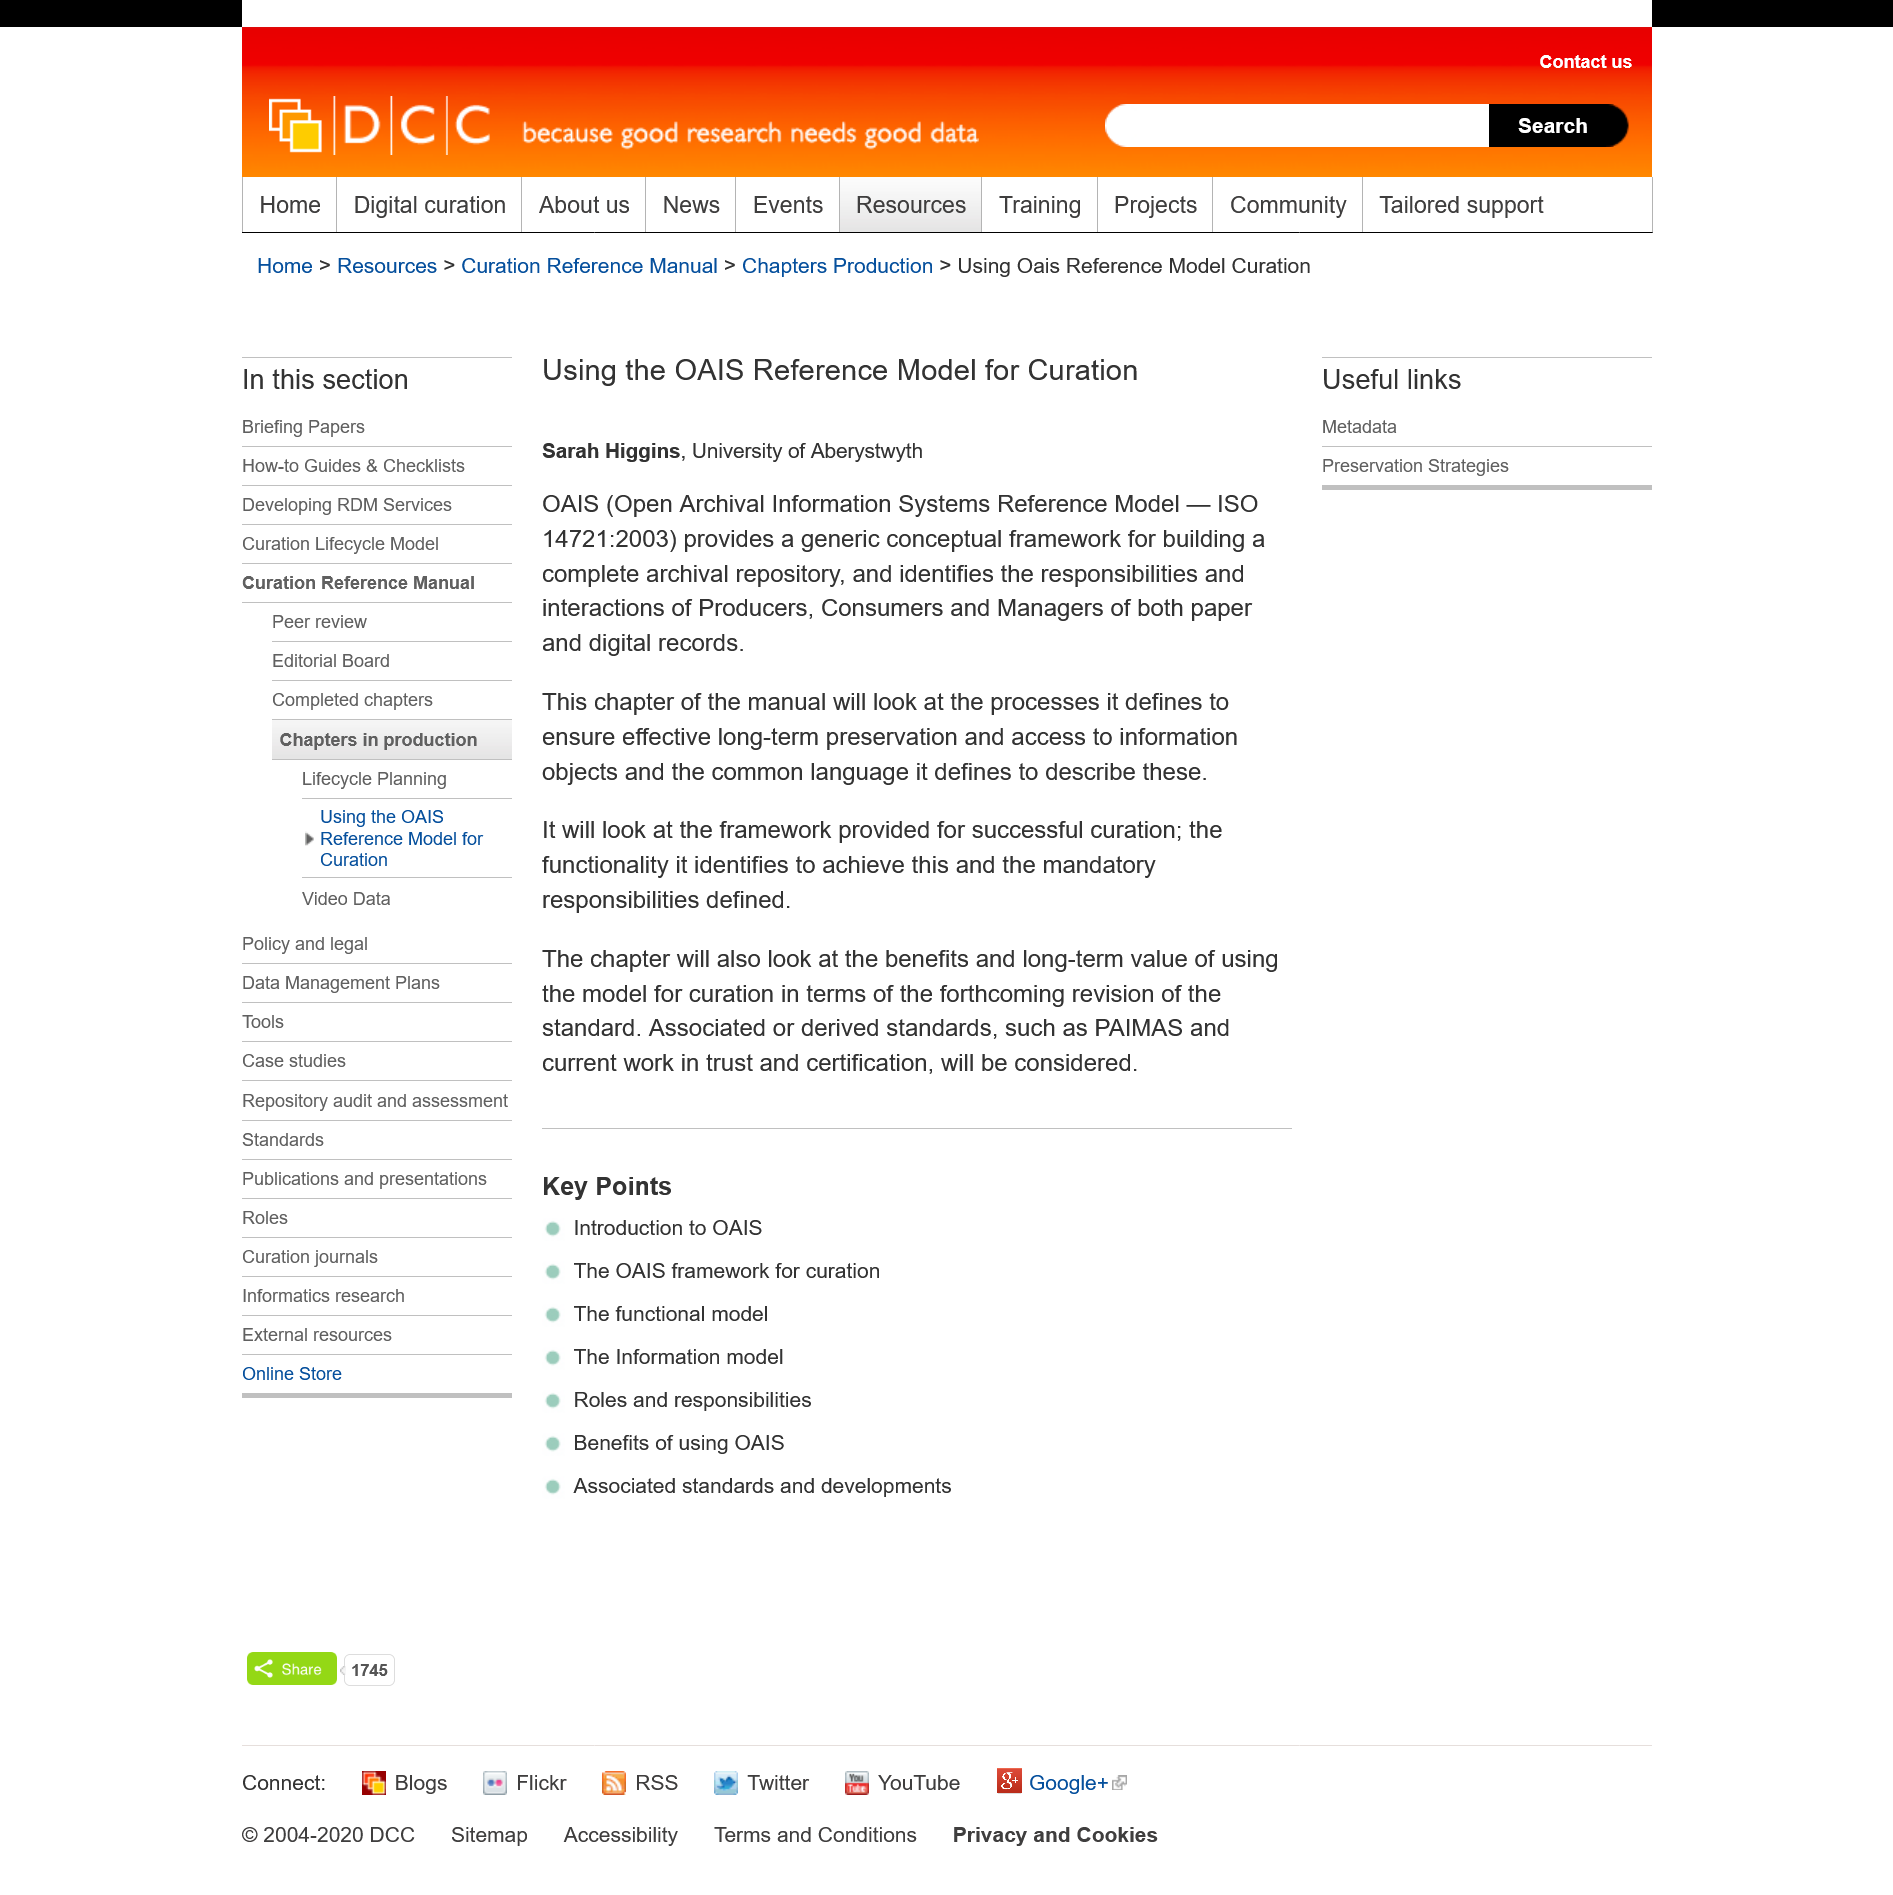Specify some key components in this picture. Sarah Higgins, a researcher from the University of Aberystwyth, investigated the OAIS Reference Model. The specified chapter in the manual outlines the processes for ensuring effective long-term preservation of information objects. OAIS provides a reference model for curation that identifies the responsibilities of producers, consumers, and managers in a complete archival repository, both in paper and digitally. It serves as a generic framework for building such a repository, providing a comprehensive and unified approach to archival management. 